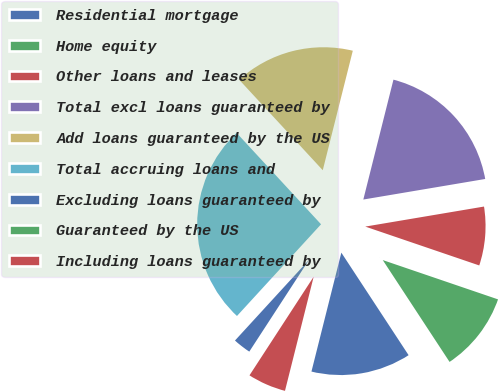Convert chart. <chart><loc_0><loc_0><loc_500><loc_500><pie_chart><fcel>Residential mortgage<fcel>Home equity<fcel>Other loans and leases<fcel>Total excl loans guaranteed by<fcel>Add loans guaranteed by the US<fcel>Total accruing loans and<fcel>Excluding loans guaranteed by<fcel>Guaranteed by the US<fcel>Including loans guaranteed by<nl><fcel>13.16%<fcel>10.53%<fcel>7.89%<fcel>18.42%<fcel>15.79%<fcel>26.32%<fcel>2.63%<fcel>0.0%<fcel>5.26%<nl></chart> 